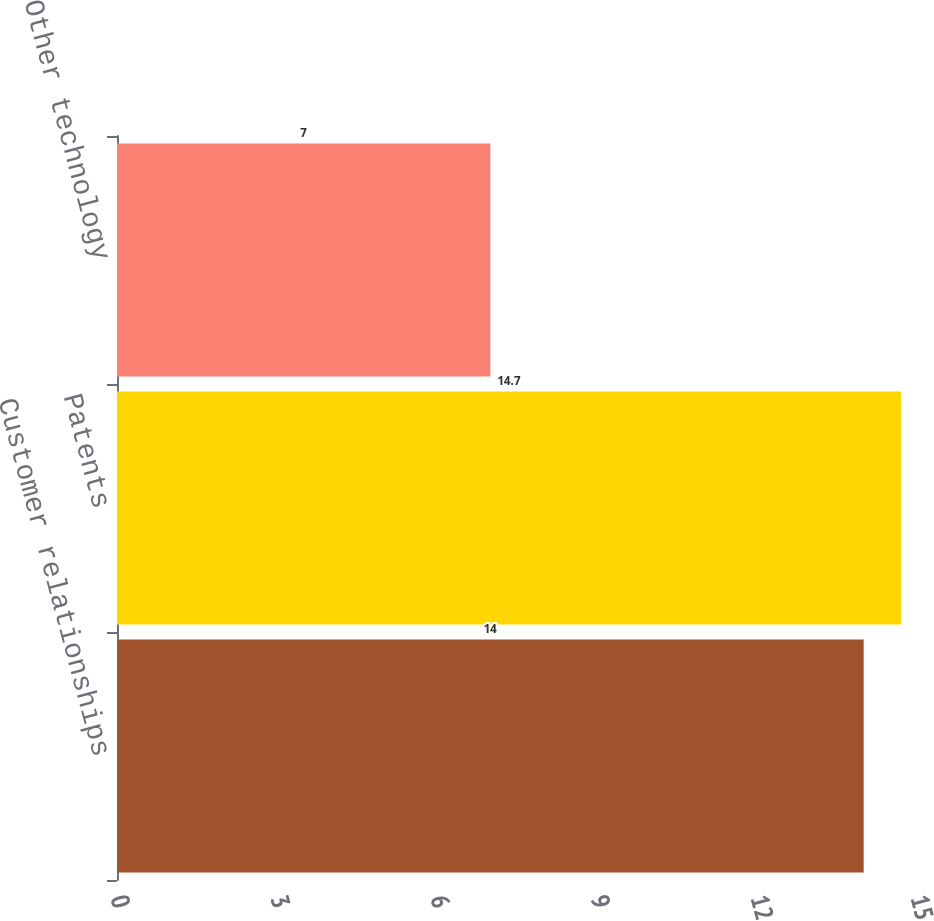Convert chart to OTSL. <chart><loc_0><loc_0><loc_500><loc_500><bar_chart><fcel>Customer relationships<fcel>Patents<fcel>Other technology<nl><fcel>14<fcel>14.7<fcel>7<nl></chart> 